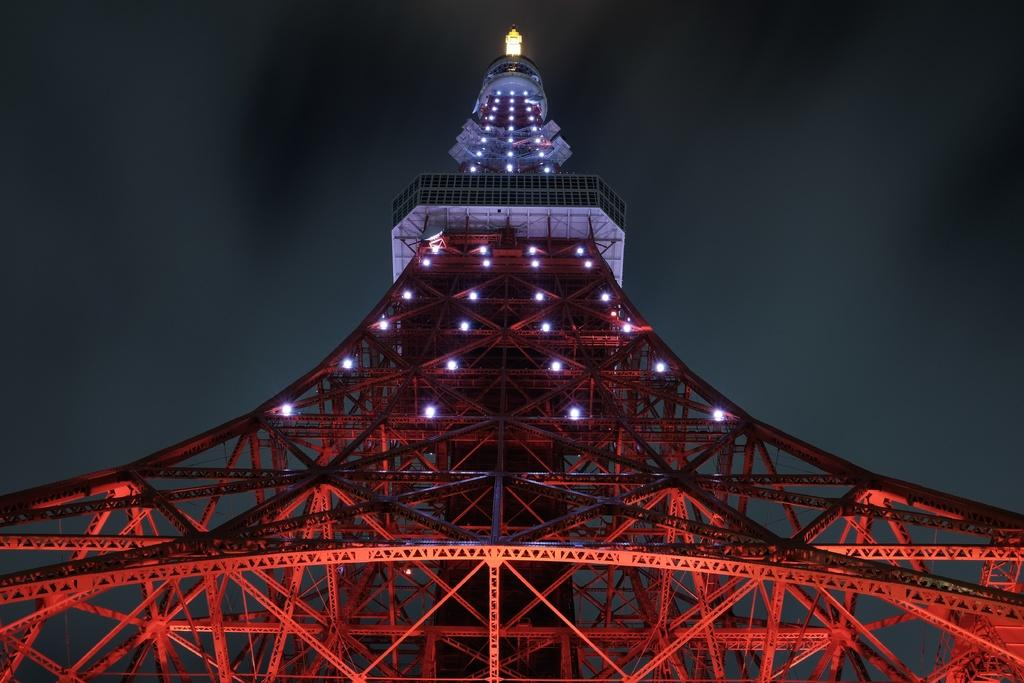What is the main structure in the image? There is a tower in the image. From where was the image captured? The image is captured from the bottom of the tower. What can be seen attached to the tower? There are many lights fixed to the tower. What color is the tower painted? The tower is painted in red color. What type of jam is being served at the door of the tower in the image? There is no jam or door present in the image; it only features a tower with lights and a red color. 